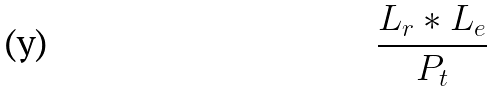<formula> <loc_0><loc_0><loc_500><loc_500>\frac { L _ { r } * L _ { e } } { P _ { t } }</formula> 